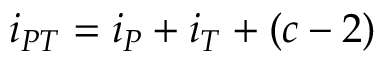<formula> <loc_0><loc_0><loc_500><loc_500>i _ { P T } = i _ { P } + i _ { T } + ( c - 2 )</formula> 